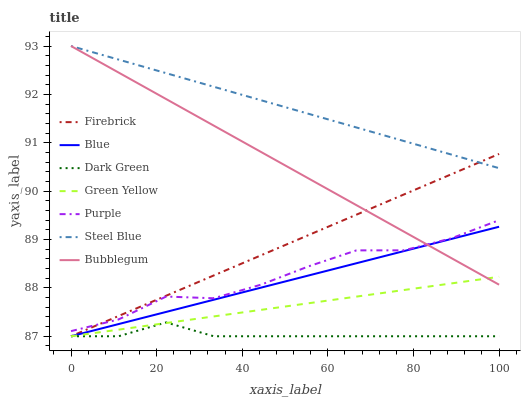Does Dark Green have the minimum area under the curve?
Answer yes or no. Yes. Does Steel Blue have the maximum area under the curve?
Answer yes or no. Yes. Does Purple have the minimum area under the curve?
Answer yes or no. No. Does Purple have the maximum area under the curve?
Answer yes or no. No. Is Steel Blue the smoothest?
Answer yes or no. Yes. Is Purple the roughest?
Answer yes or no. Yes. Is Firebrick the smoothest?
Answer yes or no. No. Is Firebrick the roughest?
Answer yes or no. No. Does Purple have the lowest value?
Answer yes or no. No. Does Bubblegum have the highest value?
Answer yes or no. Yes. Does Purple have the highest value?
Answer yes or no. No. Is Dark Green less than Steel Blue?
Answer yes or no. Yes. Is Purple greater than Blue?
Answer yes or no. Yes. Does Dark Green intersect Firebrick?
Answer yes or no. Yes. Is Dark Green less than Firebrick?
Answer yes or no. No. Is Dark Green greater than Firebrick?
Answer yes or no. No. Does Dark Green intersect Steel Blue?
Answer yes or no. No. 